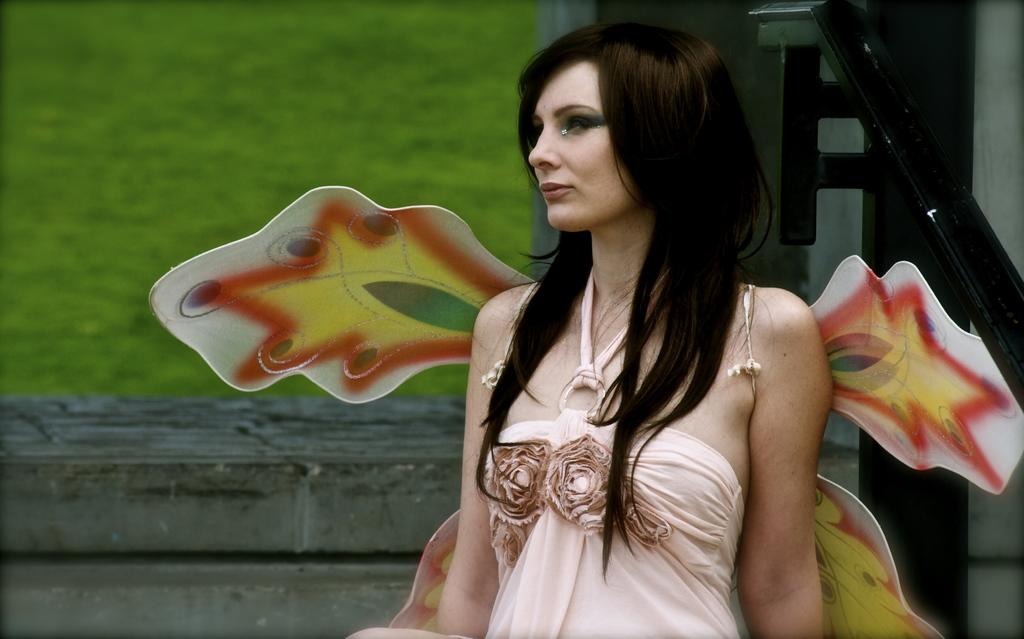Who is the main subject in the image? There is a woman in the image. What is the woman wearing? The woman is wearing a cream-colored dress. What makes the woman unique in the image? The woman has wings on her back. What can be seen in the background of the image? There are plants visible in the background of the image. What type of legal advice is the woman providing in the image? There is no indication in the image that the woman is a lawyer or providing legal advice. 